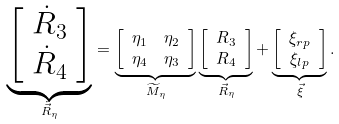<formula> <loc_0><loc_0><loc_500><loc_500>\underbrace { \left [ \begin{array} { c } \dot { R } _ { 3 } \\ \dot { R } _ { 4 } \end{array} \right ] } _ { \dot { \vec { R } } _ { \eta } } & = \underbrace { \left [ \begin{array} { c c } \eta _ { 1 } & \eta _ { 2 } \\ \eta _ { 4 } & \eta _ { 3 } \end{array} \right ] } _ { \widetilde { M } _ { \eta } } \underbrace { \left [ \begin{array} { c } R _ { 3 } \\ R _ { 4 } \end{array} \right ] } _ { \vec { R } _ { \eta } } + \underbrace { \left [ \begin{array} { c } \xi _ { r p } \\ \xi _ { l p } \end{array} \right ] } _ { \vec { \xi } } .</formula> 